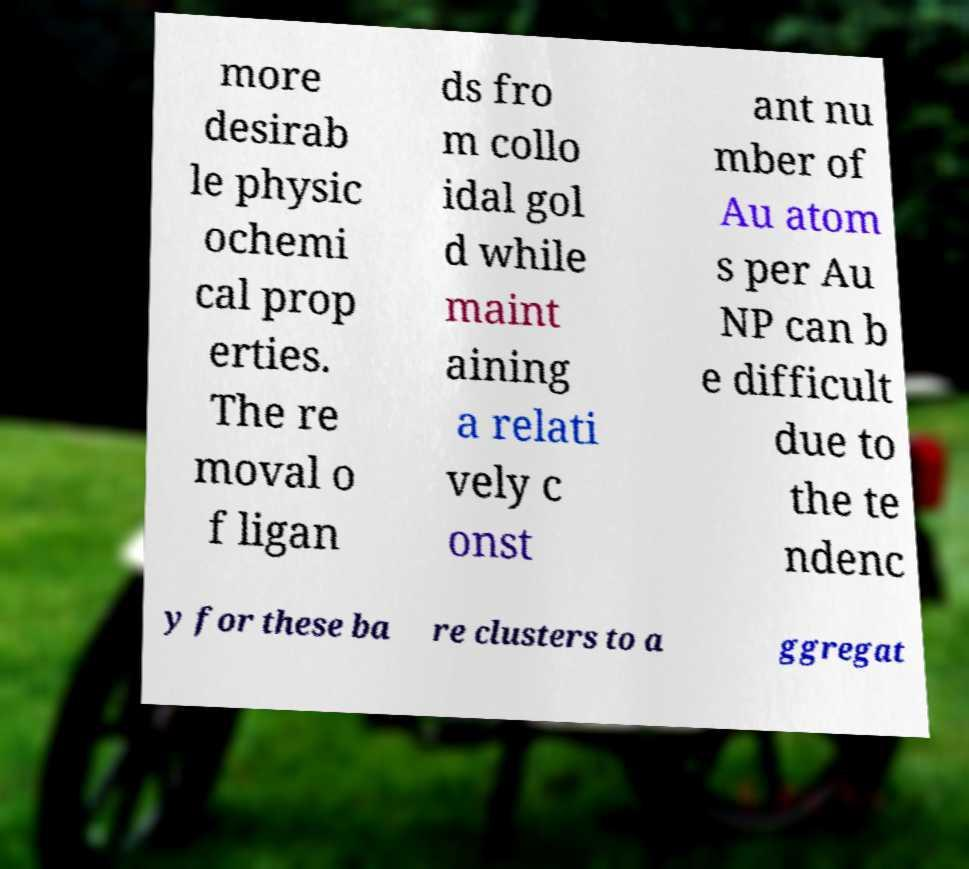For documentation purposes, I need the text within this image transcribed. Could you provide that? more desirab le physic ochemi cal prop erties. The re moval o f ligan ds fro m collo idal gol d while maint aining a relati vely c onst ant nu mber of Au atom s per Au NP can b e difficult due to the te ndenc y for these ba re clusters to a ggregat 